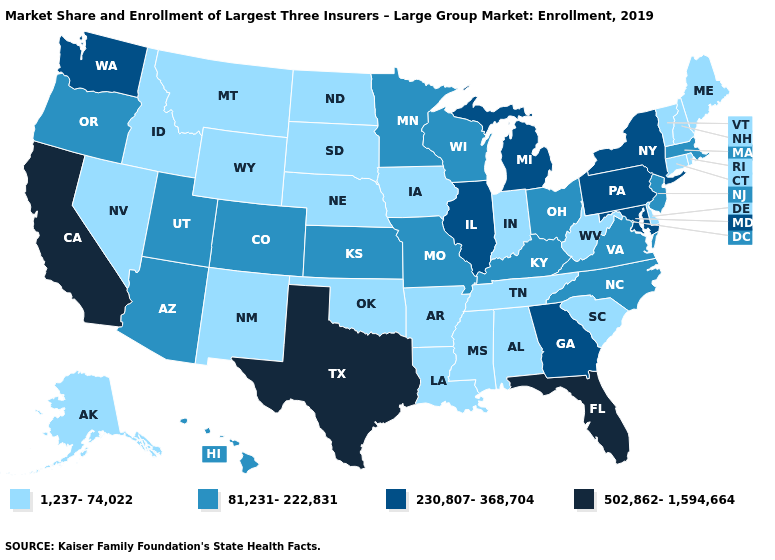What is the value of Rhode Island?
Concise answer only. 1,237-74,022. Name the states that have a value in the range 230,807-368,704?
Give a very brief answer. Georgia, Illinois, Maryland, Michigan, New York, Pennsylvania, Washington. What is the value of Maine?
Give a very brief answer. 1,237-74,022. Among the states that border Wisconsin , does Illinois have the lowest value?
Be succinct. No. What is the value of Colorado?
Write a very short answer. 81,231-222,831. What is the value of Vermont?
Quick response, please. 1,237-74,022. Which states have the highest value in the USA?
Give a very brief answer. California, Florida, Texas. What is the value of Washington?
Give a very brief answer. 230,807-368,704. What is the lowest value in the USA?
Quick response, please. 1,237-74,022. Name the states that have a value in the range 1,237-74,022?
Write a very short answer. Alabama, Alaska, Arkansas, Connecticut, Delaware, Idaho, Indiana, Iowa, Louisiana, Maine, Mississippi, Montana, Nebraska, Nevada, New Hampshire, New Mexico, North Dakota, Oklahoma, Rhode Island, South Carolina, South Dakota, Tennessee, Vermont, West Virginia, Wyoming. Does New Hampshire have a lower value than Hawaii?
Answer briefly. Yes. Name the states that have a value in the range 1,237-74,022?
Keep it brief. Alabama, Alaska, Arkansas, Connecticut, Delaware, Idaho, Indiana, Iowa, Louisiana, Maine, Mississippi, Montana, Nebraska, Nevada, New Hampshire, New Mexico, North Dakota, Oklahoma, Rhode Island, South Carolina, South Dakota, Tennessee, Vermont, West Virginia, Wyoming. Among the states that border South Carolina , which have the highest value?
Write a very short answer. Georgia. What is the value of Minnesota?
Answer briefly. 81,231-222,831. What is the value of Ohio?
Keep it brief. 81,231-222,831. 